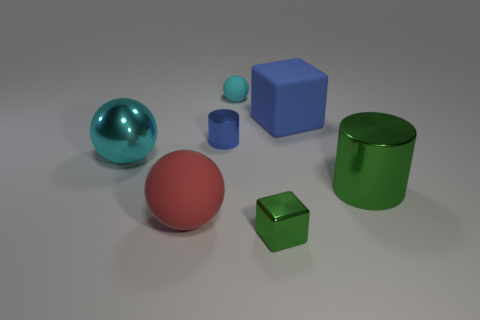Add 1 cyan spheres. How many objects exist? 8 Subtract all large spheres. How many spheres are left? 1 Subtract all blue cylinders. How many cylinders are left? 1 Subtract 1 spheres. How many spheres are left? 2 Subtract all cylinders. How many objects are left? 5 Subtract all cyan cubes. Subtract all yellow cylinders. How many cubes are left? 2 Subtract all gray cubes. How many blue cylinders are left? 1 Subtract all green metallic spheres. Subtract all big cyan shiny things. How many objects are left? 6 Add 5 tiny blue metal things. How many tiny blue metal things are left? 6 Add 6 tiny cubes. How many tiny cubes exist? 7 